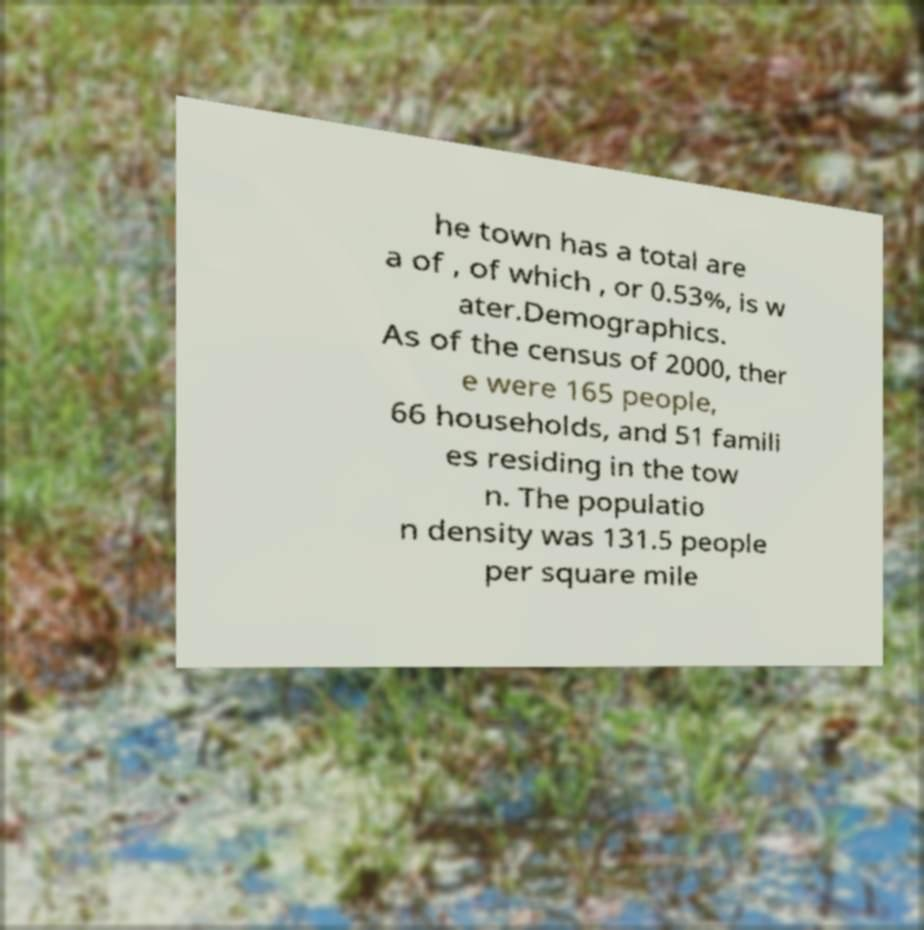Could you assist in decoding the text presented in this image and type it out clearly? he town has a total are a of , of which , or 0.53%, is w ater.Demographics. As of the census of 2000, ther e were 165 people, 66 households, and 51 famili es residing in the tow n. The populatio n density was 131.5 people per square mile 